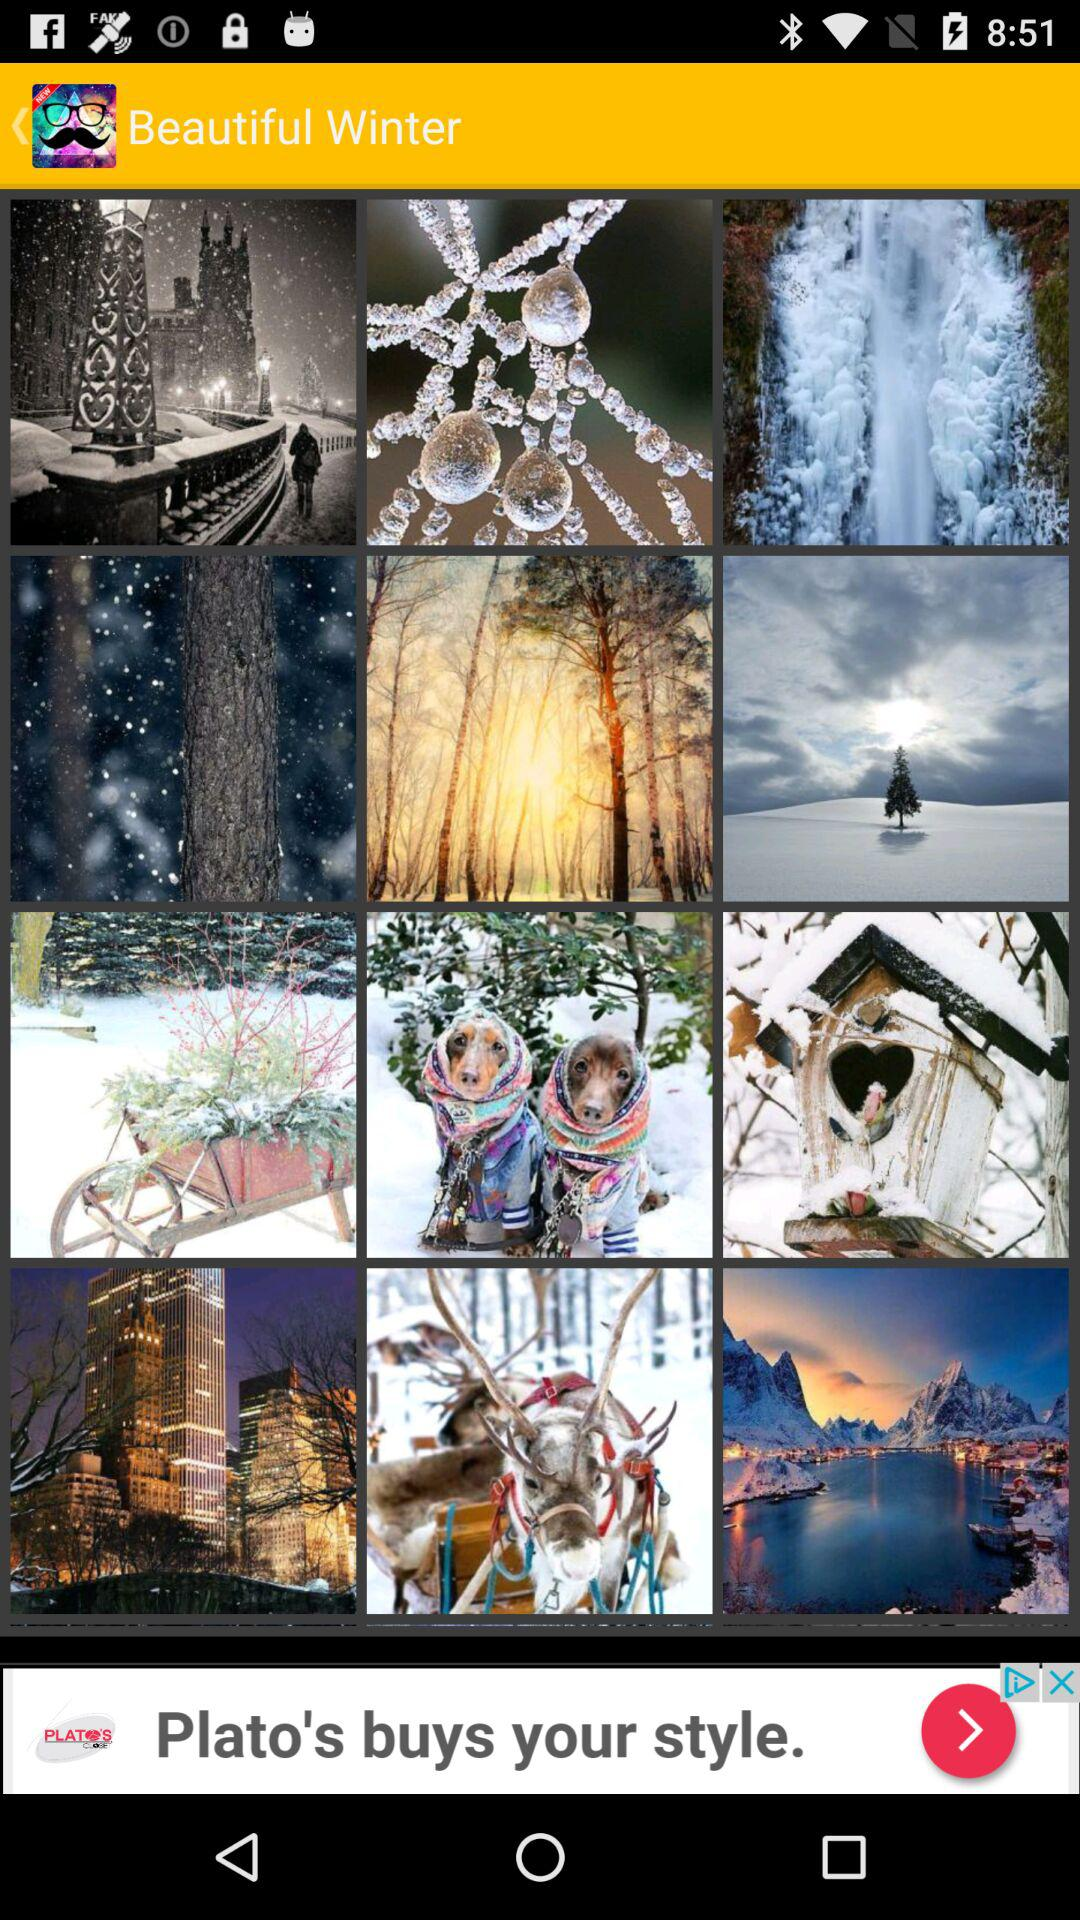What is the application name? The application name is "Beautiful Winter". 